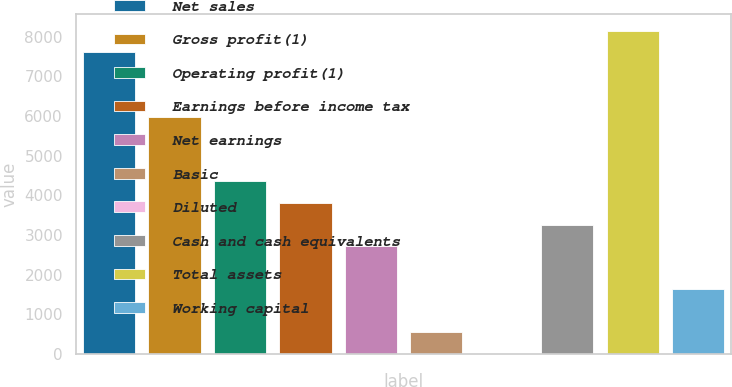<chart> <loc_0><loc_0><loc_500><loc_500><bar_chart><fcel>Net sales<fcel>Gross profit(1)<fcel>Operating profit(1)<fcel>Earnings before income tax<fcel>Net earnings<fcel>Basic<fcel>Diluted<fcel>Cash and cash equivalents<fcel>Total assets<fcel>Working capital<nl><fcel>7612.85<fcel>5981.93<fcel>4351.01<fcel>3807.37<fcel>2720.09<fcel>545.53<fcel>1.89<fcel>3263.73<fcel>8156.49<fcel>1632.81<nl></chart> 